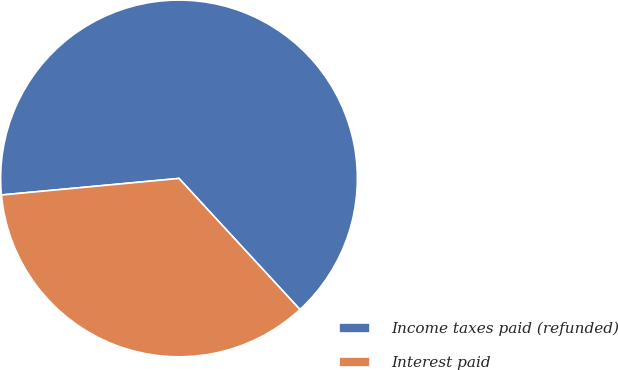<chart> <loc_0><loc_0><loc_500><loc_500><pie_chart><fcel>Income taxes paid (refunded)<fcel>Interest paid<nl><fcel>64.62%<fcel>35.38%<nl></chart> 